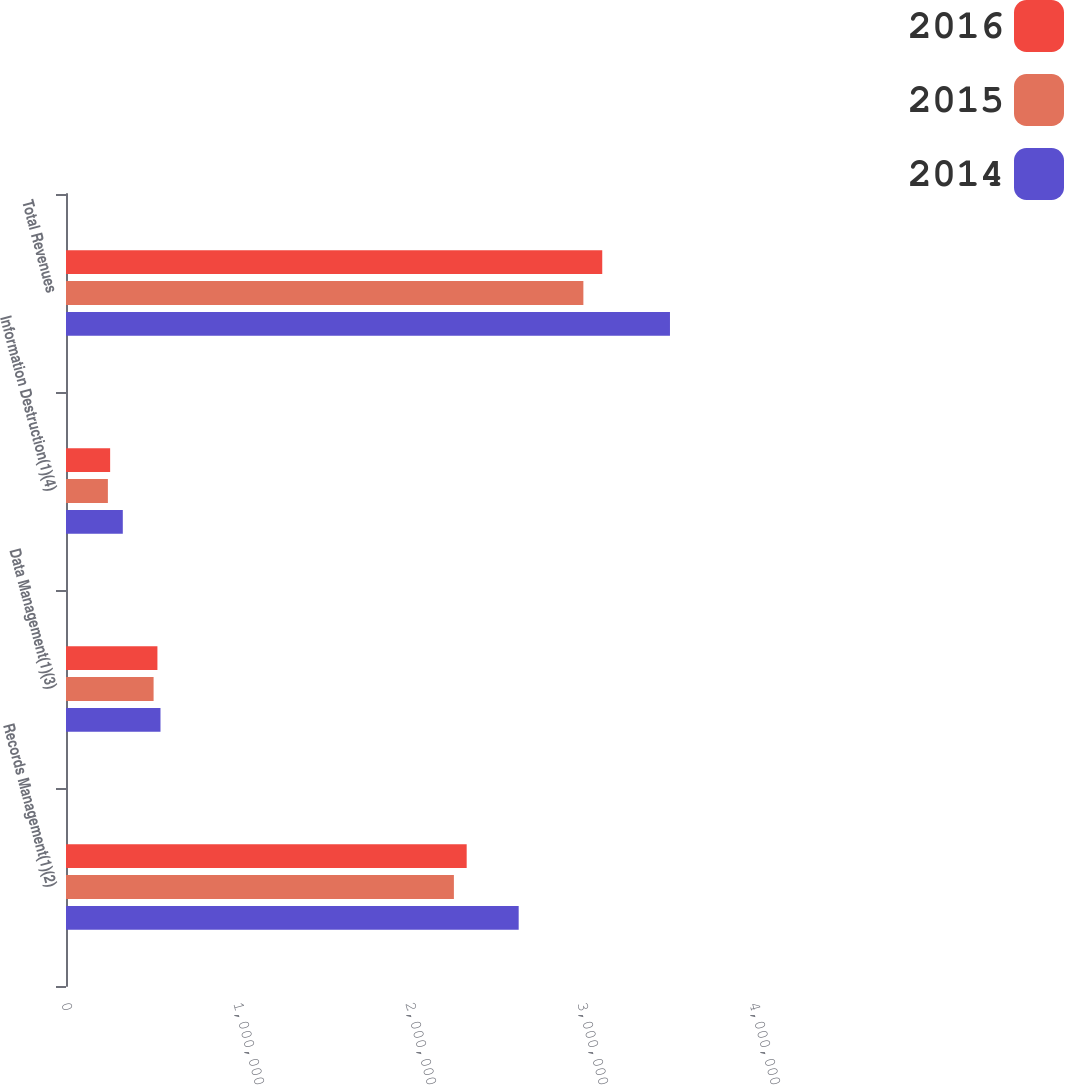Convert chart to OTSL. <chart><loc_0><loc_0><loc_500><loc_500><stacked_bar_chart><ecel><fcel>Records Management(1)(2)<fcel>Data Management(1)(3)<fcel>Information Destruction(1)(4)<fcel>Total Revenues<nl><fcel>2016<fcel>2.32955e+06<fcel>531516<fcel>256631<fcel>3.11769e+06<nl><fcel>2015<fcel>2.25521e+06<fcel>509261<fcel>243509<fcel>3.00798e+06<nl><fcel>2014<fcel>2.6319e+06<fcel>549335<fcel>330223<fcel>3.51145e+06<nl></chart> 